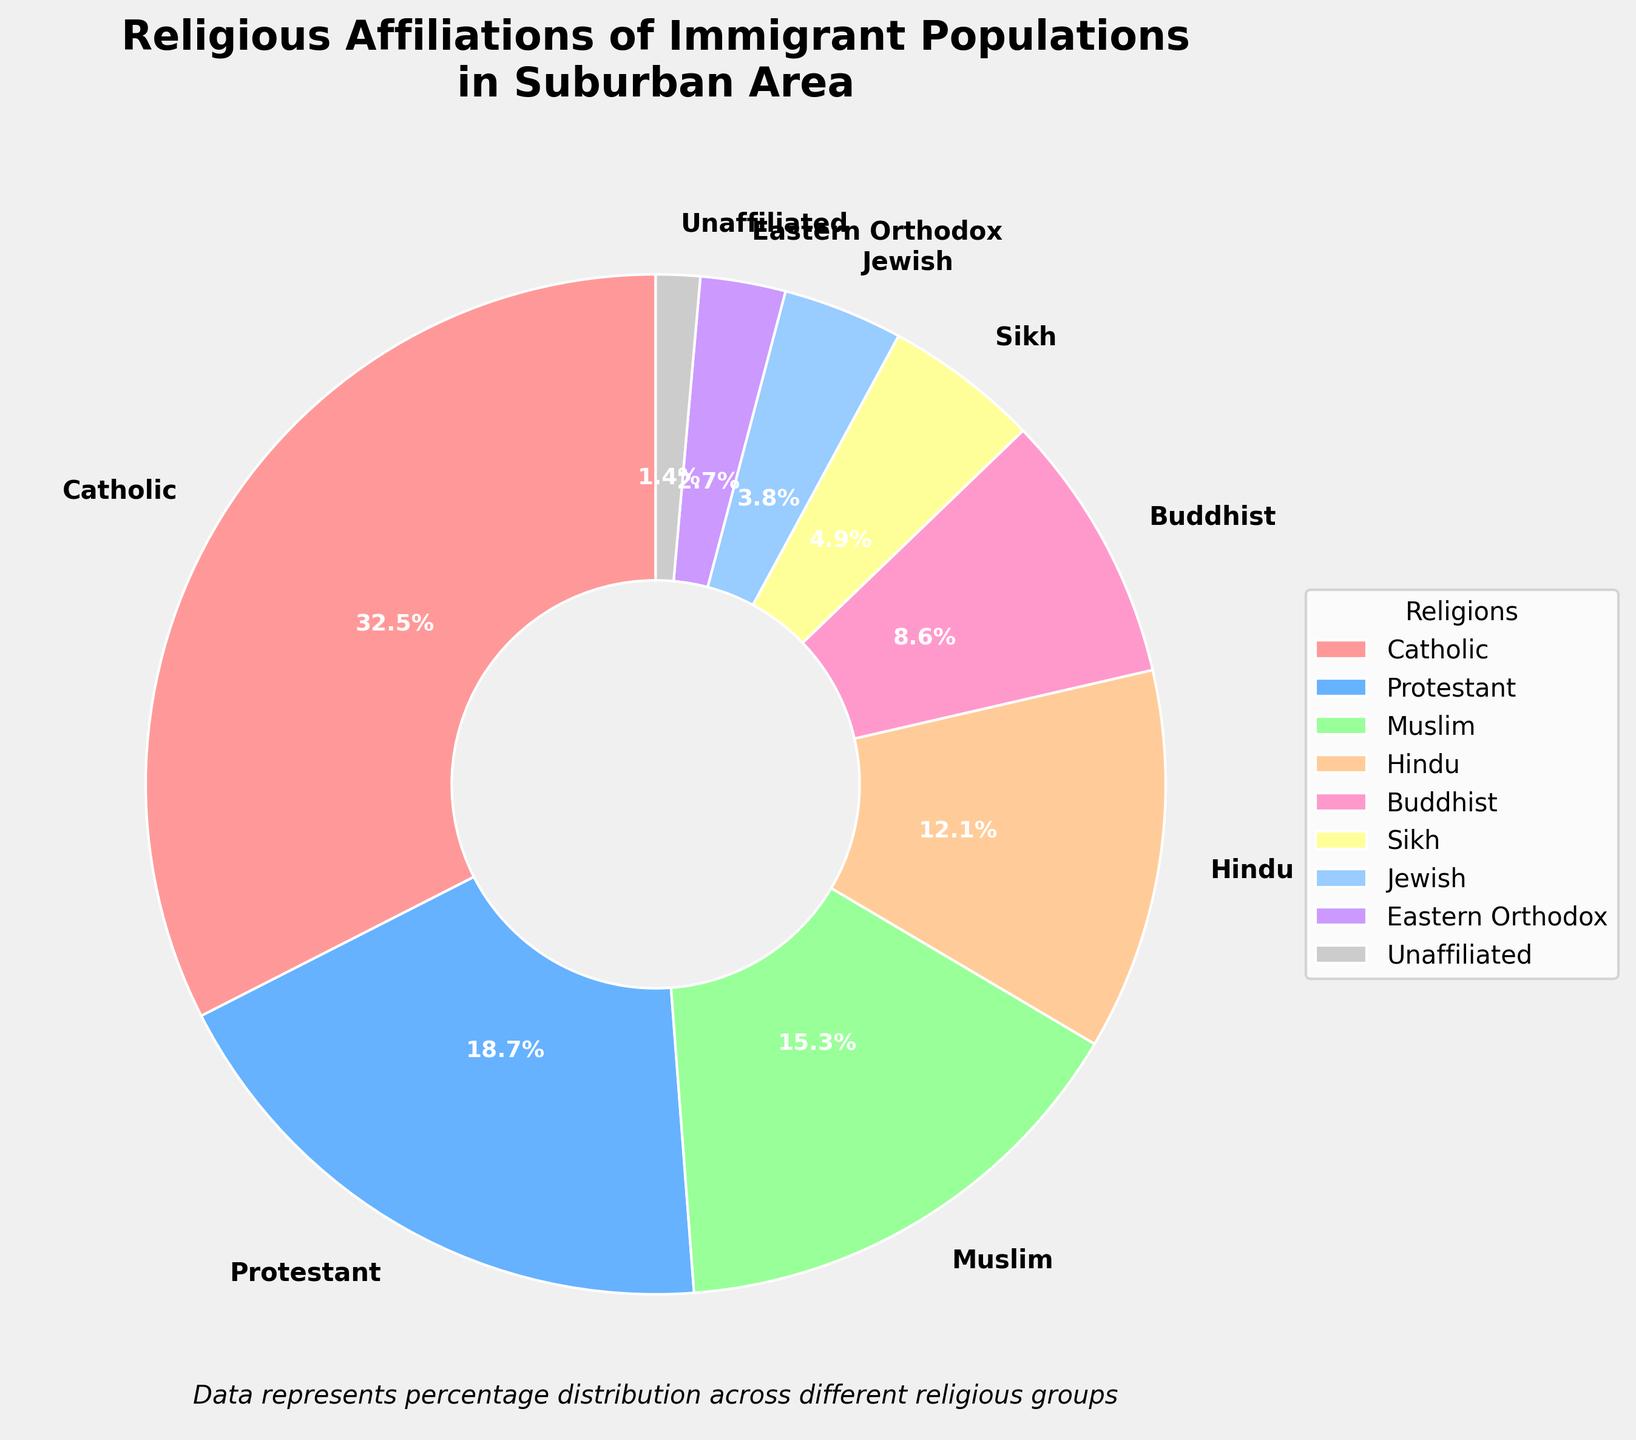What is the most common religious affiliation among immigrant populations in the suburban area? The most common religious affiliation can be identified by looking at the percentage values in the pie chart. Catholic has the highest percentage at 32.5%.
Answer: Catholic Which two religious affiliations together account for less than 10% of the population? By examining the chart, we can see that Eastern Orthodox (2.7%) and Unaffiliated (1.4%) together account for 4.1%, which is less than 10%.
Answer: Eastern Orthodox, Unaffiliated How does the percentage of Protestants compare to that of Hindus? By comparing the two values, Protestants (18.7%) have a higher percentage than Hindus (12.1%).
Answer: Protestants have a higher percentage than Hindus Which religious group has a smaller percentage: Jewish or Sikh? By checking the values, Jewish (3.8%) has a smaller percentage than Sikh (4.9%).
Answer: Jewish What is the combined percentage of Muslim and Hindu populations? Adding the percentages of Muslims (15.3%) and Hindus (12.1%) gives a total of 27.4%.
Answer: 27.4% Do Catholics and Protestants together constitute the majority of the population? Adding the percentages of Catholics (32.5%) and Protestants (18.7%), we get 51.2%, which is more than 50%, thus indicating a majority.
Answer: Yes What percentage of the population is affiliated with Eastern religions (Hindu, Buddhist, Sikh)? Adding the percentages of Hindu (12.1%), Buddhist (8.6%), and Sikh (4.9%) gives a total of 25.6%.
Answer: 25.6% Which religious group has the third highest percentage, and what is it? The pie chart shows the third highest percentage after Catholic (32.5%) and Protestant (18.7%) is Muslim at 15.3%.
Answer: Muslim, 15.3% What percentage of the population is Protestant, and how does it compare to the percentage of Buddhists and Jews combined? Protestant percentage is 18.7%. The combined percentage of Buddhists (8.6%) and Jews (3.8%) is 12.4%. Therefore, Protestants have a higher percentage than Buddhists and Jews combined.
Answer: 18.7%, Protestants have a higher percentage Considering the groups Muslim, Hindu, and Buddhist, which has the smallest percentage, and what is it? By checking the values, Buddhist (8.6%) has the smallest percentage among Muslim (15.3%), Hindu (12.1%), and Buddhist (8.6%).
Answer: Buddhist, 8.6% 